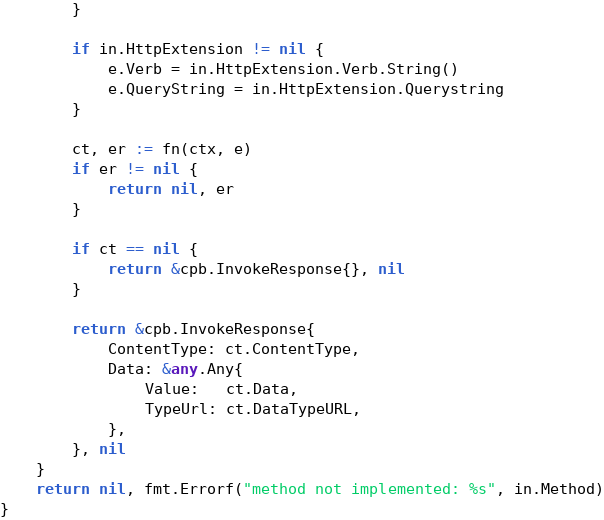<code> <loc_0><loc_0><loc_500><loc_500><_Go_>		}

		if in.HttpExtension != nil {
			e.Verb = in.HttpExtension.Verb.String()
			e.QueryString = in.HttpExtension.Querystring
		}

		ct, er := fn(ctx, e)
		if er != nil {
			return nil, er
		}

		if ct == nil {
			return &cpb.InvokeResponse{}, nil
		}

		return &cpb.InvokeResponse{
			ContentType: ct.ContentType,
			Data: &any.Any{
				Value:   ct.Data,
				TypeUrl: ct.DataTypeURL,
			},
		}, nil
	}
	return nil, fmt.Errorf("method not implemented: %s", in.Method)
}
</code> 